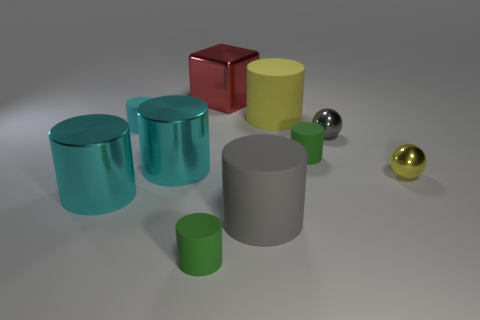What number of shiny things are either large yellow cylinders or balls?
Make the answer very short. 2. There is a yellow thing in front of the large yellow cylinder to the right of the red shiny object; what number of small cyan rubber objects are to the right of it?
Your response must be concise. 0. There is a green matte cylinder to the right of the cube; does it have the same size as the ball behind the small yellow metal object?
Offer a very short reply. Yes. There is a gray object that is the same shape as the tiny cyan matte object; what material is it?
Make the answer very short. Rubber. What number of tiny objects are cylinders or shiny things?
Your answer should be very brief. 5. What is the tiny yellow ball made of?
Your response must be concise. Metal. What material is the thing that is to the left of the gray shiny thing and on the right side of the large yellow object?
Your response must be concise. Rubber. There is a cube; is its color the same as the large matte thing in front of the small gray shiny thing?
Provide a succinct answer. No. There is a yellow cylinder that is the same size as the gray cylinder; what is it made of?
Your answer should be very brief. Rubber. Is there a large cylinder made of the same material as the red block?
Make the answer very short. Yes. 